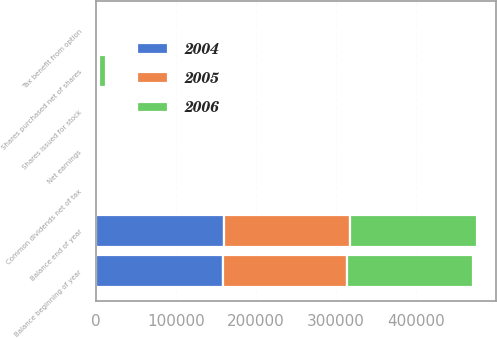<chart> <loc_0><loc_0><loc_500><loc_500><stacked_bar_chart><ecel><fcel>Balance beginning of year<fcel>Shares issued for stock<fcel>Balance end of year<fcel>Shares purchased net of shares<fcel>Tax benefit from option<fcel>Net earnings<fcel>Common dividends net of tax<nl><fcel>2004<fcel>158383<fcel>28.7<fcel>160027<fcel>1707<fcel>7.5<fcel>329.6<fcel>40.3<nl><fcel>2006<fcel>157506<fcel>15.5<fcel>158383<fcel>9368<fcel>7.3<fcel>272.1<fcel>41.1<nl><fcel>2005<fcel>155885<fcel>29.8<fcel>157506<fcel>1709<fcel>13.7<fcel>302.1<fcel>36.9<nl></chart> 